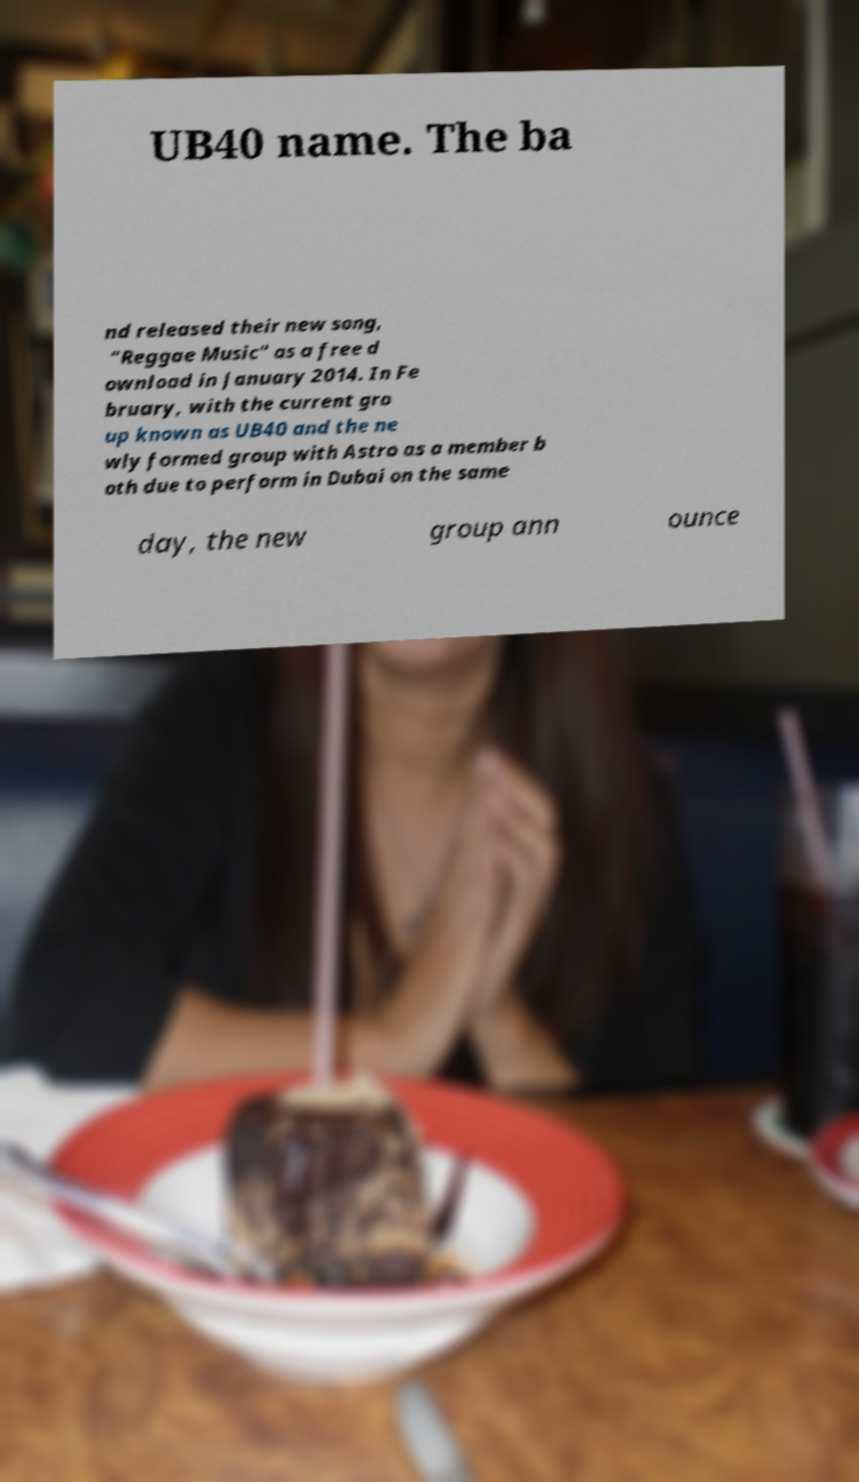Please identify and transcribe the text found in this image. UB40 name. The ba nd released their new song, "Reggae Music" as a free d ownload in January 2014. In Fe bruary, with the current gro up known as UB40 and the ne wly formed group with Astro as a member b oth due to perform in Dubai on the same day, the new group ann ounce 